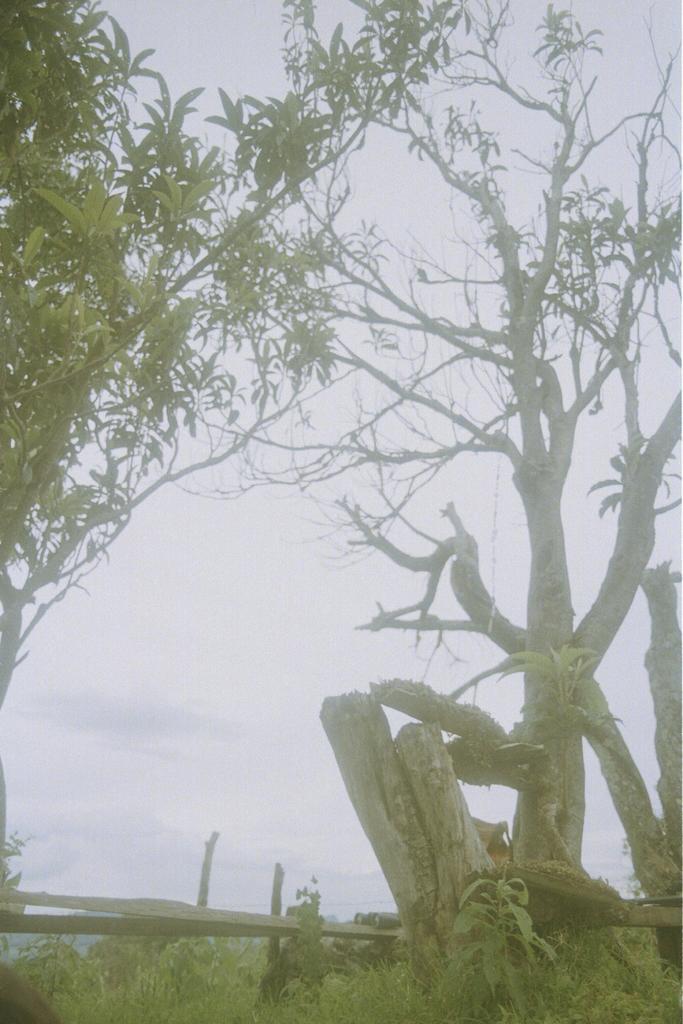Describe this image in one or two sentences. In this image, we can see trees and there is a fence. At the bottom, there is grass and at the top, there is sky. 